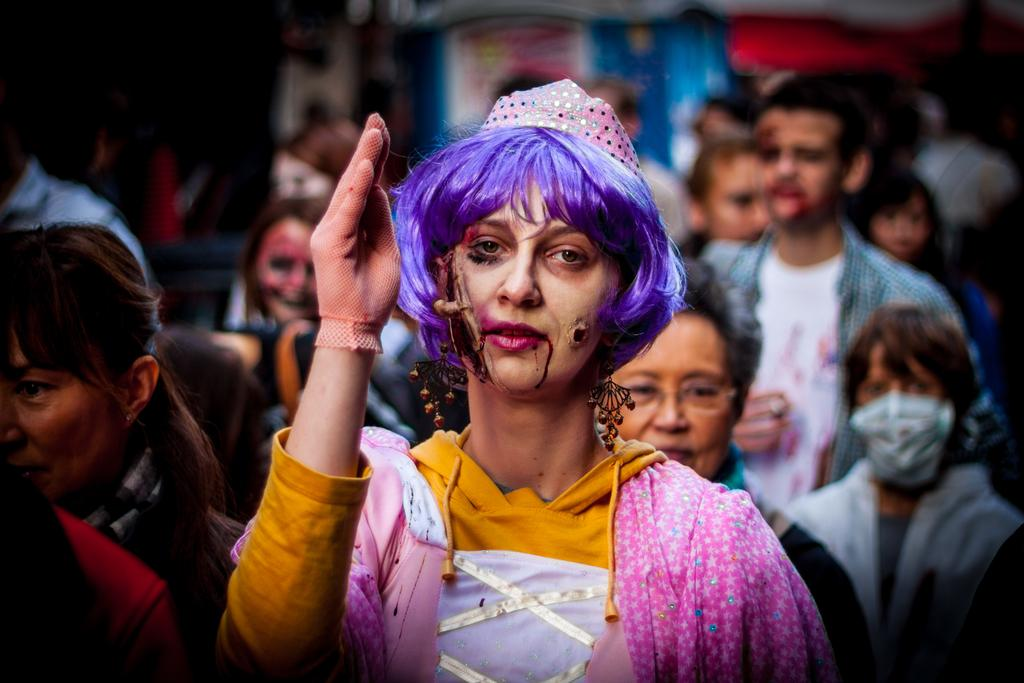Who is the main subject in the image? There is a lady in the image. What is the lady wearing on her head? The lady is wearing a cap. What else is the lady wearing? The lady is wearing gloves. What can be seen in the background of the image? There are many people in the background of the image. How would you describe the background in terms of clarity? The background is blurry. Can you see a police officer wearing a veil in the image? There is no police officer or veil present in the image. Is there a tiger visible in the background of the image? There is no tiger present in the image. 